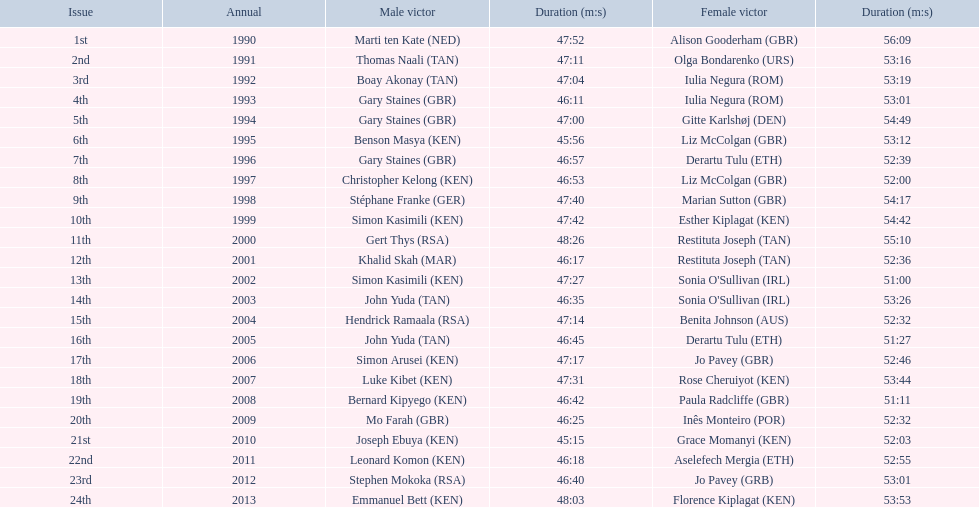Who were all the runners' times between 1990 and 2013? 47:52, 56:09, 47:11, 53:16, 47:04, 53:19, 46:11, 53:01, 47:00, 54:49, 45:56, 53:12, 46:57, 52:39, 46:53, 52:00, 47:40, 54:17, 47:42, 54:42, 48:26, 55:10, 46:17, 52:36, 47:27, 51:00, 46:35, 53:26, 47:14, 52:32, 46:45, 51:27, 47:17, 52:46, 47:31, 53:44, 46:42, 51:11, 46:25, 52:32, 45:15, 52:03, 46:18, 52:55, 46:40, 53:01, 48:03, 53:53. Which was the fastest time? 45:15. Who ran that time? Joseph Ebuya (KEN). 